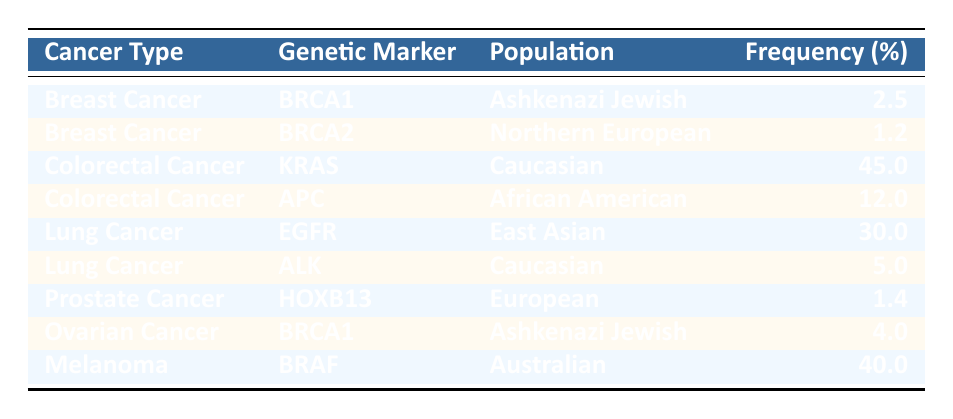What is the frequency of the BRCA1 genetic marker in Ashkenazi Jewish populations for Breast Cancer? The table lists the frequency of the BRCA1 genetic marker for Breast Cancer under the population Ashkenazi Jewish, which is shown as 2.5%.
Answer: 2.5% Which genetic marker has the highest frequency in Colorectal Cancer among Caucasian populations? From the table, the KRAS genetic marker shows a frequency of 45% for Colorectal Cancer in Caucasian populations, which is higher than the APC genetic marker at 12%.
Answer: KRAS Does Lung Cancer have any genetic markers with a frequency greater than 20%? By examining the table, the EGFR genetic marker for Lung Cancer in East Asian populations has a frequency of 30%, which is indeed greater than 20%.
Answer: Yes What is the average frequency of the genetic markers listed for Ovarian Cancer? The table shows one genetic marker for Ovarian Cancer, BRCA1, with a frequency of 4%. Since there's only one data point, the average is also 4%.
Answer: 4% Is the frequency of the ALK genetic marker higher in Caucasian populations compared to the frequency of the HOXB13 genetic marker in European populations? The frequency for ALK in Caucasian populations is 5%, while HOXB13 in European populations is 1.4%. Thus, 5% is indeed higher than 1.4%.
Answer: Yes How many different populations are represented in the table for Breast Cancer? The table indicates two entries under Breast Cancer: one for Ashkenazi Jewish with BRCA1 and one for Northern European with BRCA2, summing a total of two different populations.
Answer: 2 What is the total frequency of the genetic markers for all cancers listed in the table? First, identify all the frequencies: 2.5 (BRCA1) + 1.2 (BRCA2) + 45 (KRAS) + 12 (APC) + 30 (EGFR) + 5 (ALK) + 1.4 (HOXB13) + 4 (BRCA1) + 40 (BRAF) = 139.1%. Thus, the total frequency is 139.1%.
Answer: 139.1% Which cancer type has the lowest frequency listed for its genetic markers? Reviewing the entries, the lowest frequency for genetic markers is 1.2% for the BRCA2 genetic marker associated with Breast Cancer in Northern European populations.
Answer: 1.2% 